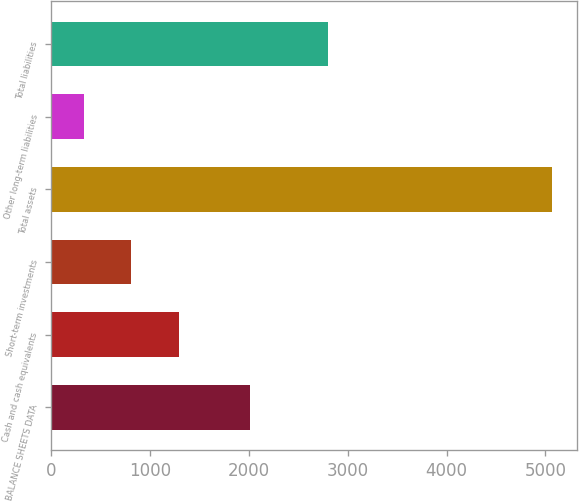Convert chart. <chart><loc_0><loc_0><loc_500><loc_500><bar_chart><fcel>BALANCE SHEETS DATA<fcel>Cash and cash equivalents<fcel>Short-term investments<fcel>Total assets<fcel>Other long-term liabilities<fcel>Total liabilities<nl><fcel>2013<fcel>1292<fcel>801.3<fcel>5070<fcel>327<fcel>2803<nl></chart> 